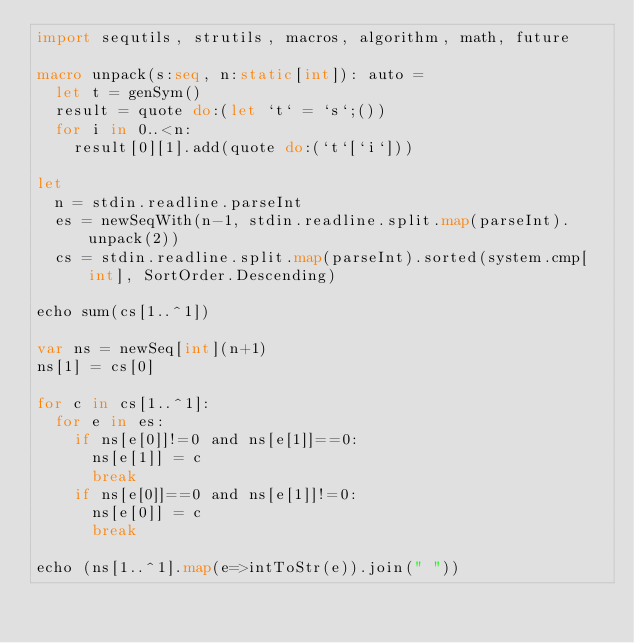Convert code to text. <code><loc_0><loc_0><loc_500><loc_500><_Nim_>import sequtils, strutils, macros, algorithm, math, future

macro unpack(s:seq, n:static[int]): auto =
  let t = genSym()
  result = quote do:(let `t` = `s`;())
  for i in 0..<n:
    result[0][1].add(quote do:(`t`[`i`]))

let
  n = stdin.readline.parseInt
  es = newSeqWith(n-1, stdin.readline.split.map(parseInt).unpack(2))
  cs = stdin.readline.split.map(parseInt).sorted(system.cmp[int], SortOrder.Descending)

echo sum(cs[1..^1])

var ns = newSeq[int](n+1)
ns[1] = cs[0]

for c in cs[1..^1]:
  for e in es:
    if ns[e[0]]!=0 and ns[e[1]]==0:
      ns[e[1]] = c
      break
    if ns[e[0]]==0 and ns[e[1]]!=0:
      ns[e[0]] = c
      break

echo (ns[1..^1].map(e=>intToStr(e)).join(" "))
</code> 